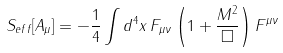<formula> <loc_0><loc_0><loc_500><loc_500>S _ { e f f } [ A _ { \mu } ] = - \frac { 1 } { 4 } \int d ^ { 4 } x \, F _ { \mu \nu } \left ( 1 + \frac { M ^ { 2 } } { \Box } \right ) F ^ { \mu \nu }</formula> 